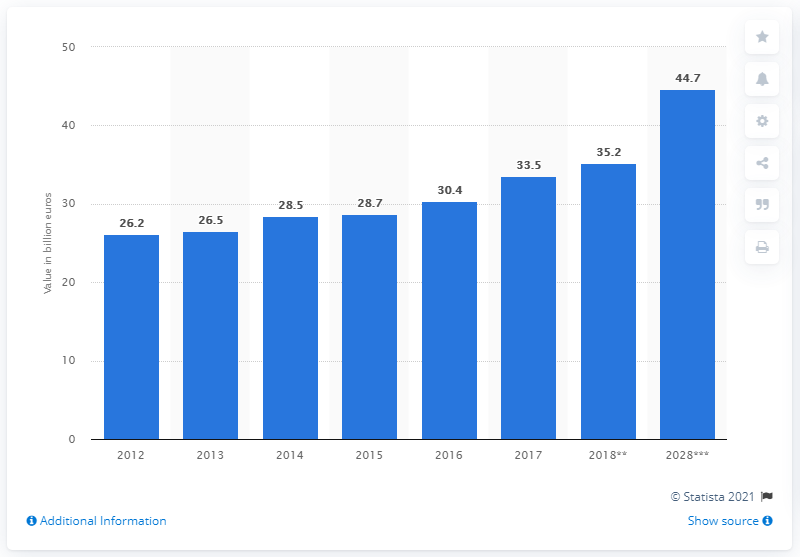Outline some significant characteristics in this image. In 2017, the travel and tourism industry contributed 33.5% to Portugal's GDP. 